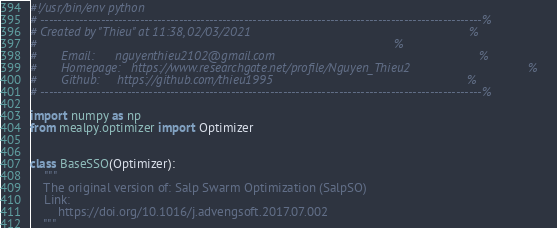Convert code to text. <code><loc_0><loc_0><loc_500><loc_500><_Python_>#!/usr/bin/env python
# ------------------------------------------------------------------------------------------------------%
# Created by "Thieu" at 11:38, 02/03/2021                                                               %
#                                                                                                       %
#       Email:      nguyenthieu2102@gmail.com                                                           %
#       Homepage:   https://www.researchgate.net/profile/Nguyen_Thieu2                                  %
#       Github:     https://github.com/thieu1995                                                        %
# ------------------------------------------------------------------------------------------------------%

import numpy as np
from mealpy.optimizer import Optimizer


class BaseSSO(Optimizer):
    """
    The original version of: Salp Swarm Optimization (SalpSO)
    Link:
        https://doi.org/10.1016/j.advengsoft.2017.07.002
    """
</code> 